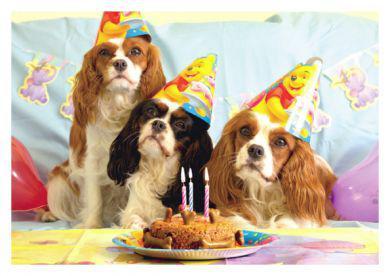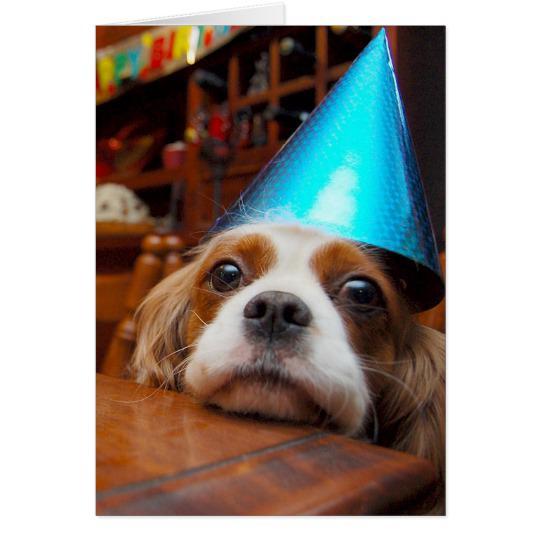The first image is the image on the left, the second image is the image on the right. Given the left and right images, does the statement "at least one dog in the image pair is wearing a party hat" hold true? Answer yes or no. Yes. The first image is the image on the left, the second image is the image on the right. Given the left and right images, does the statement "A birthday hat has been placed on at least one puppy's head." hold true? Answer yes or no. Yes. 